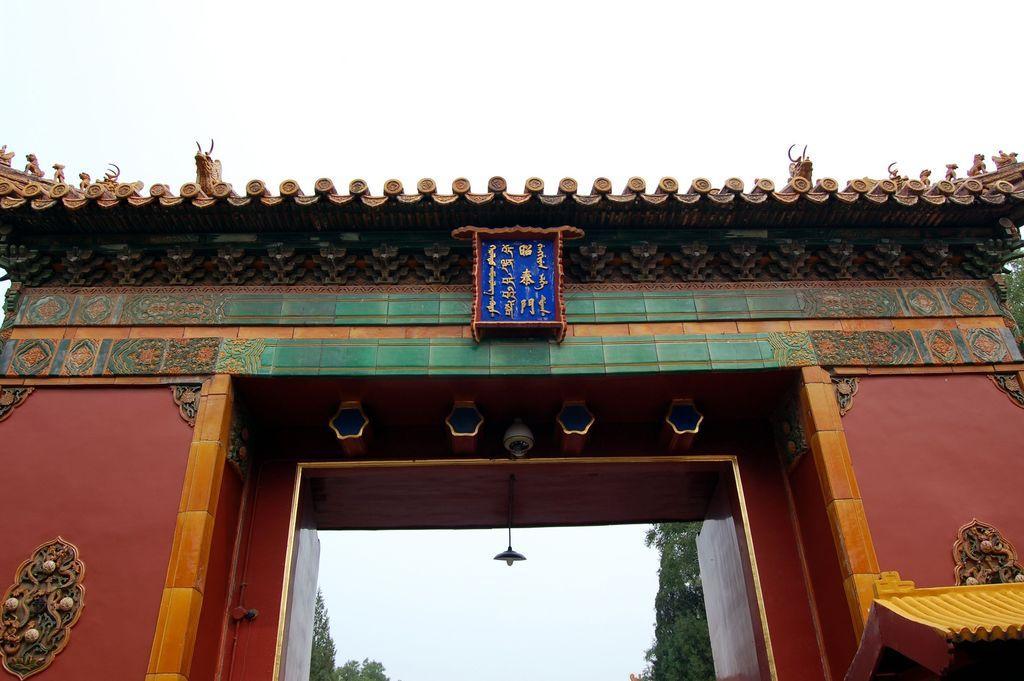Can you describe this image briefly? In this image we can see an arch and there are texts written on a platform and it is on the arch and we can see a light is hanging and security camera on the arch. In the background we can see trees and sky. 